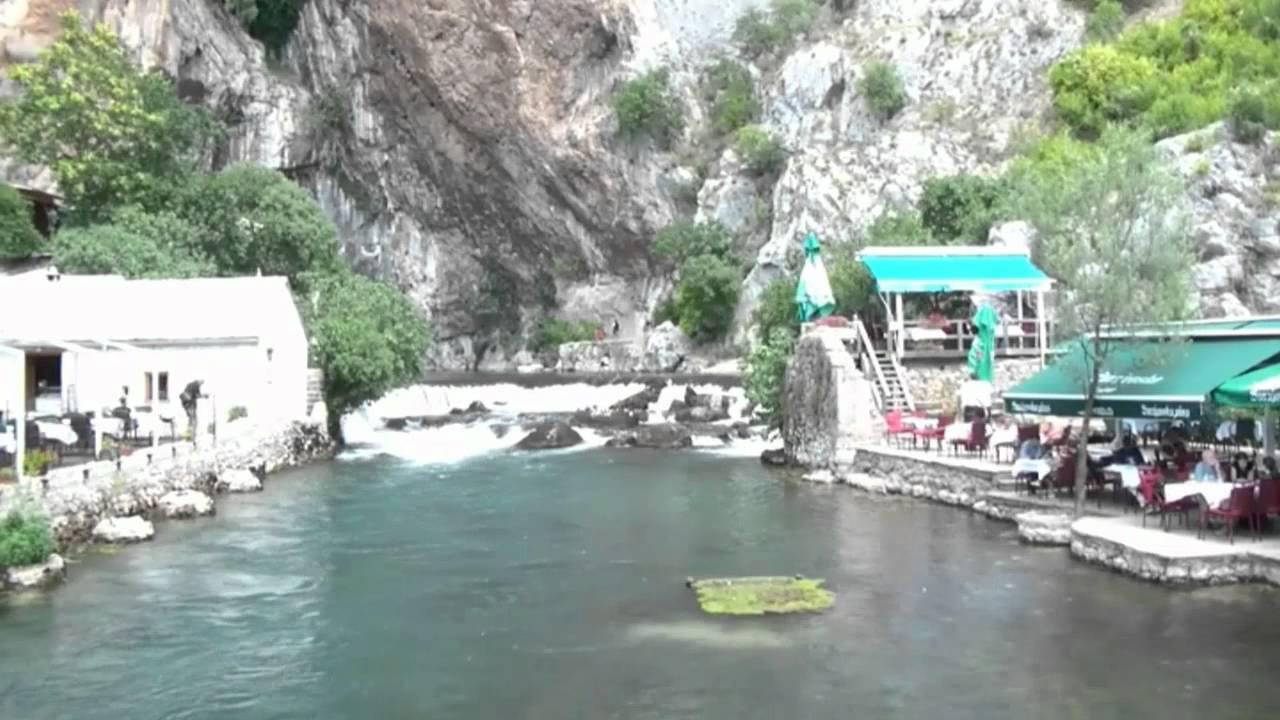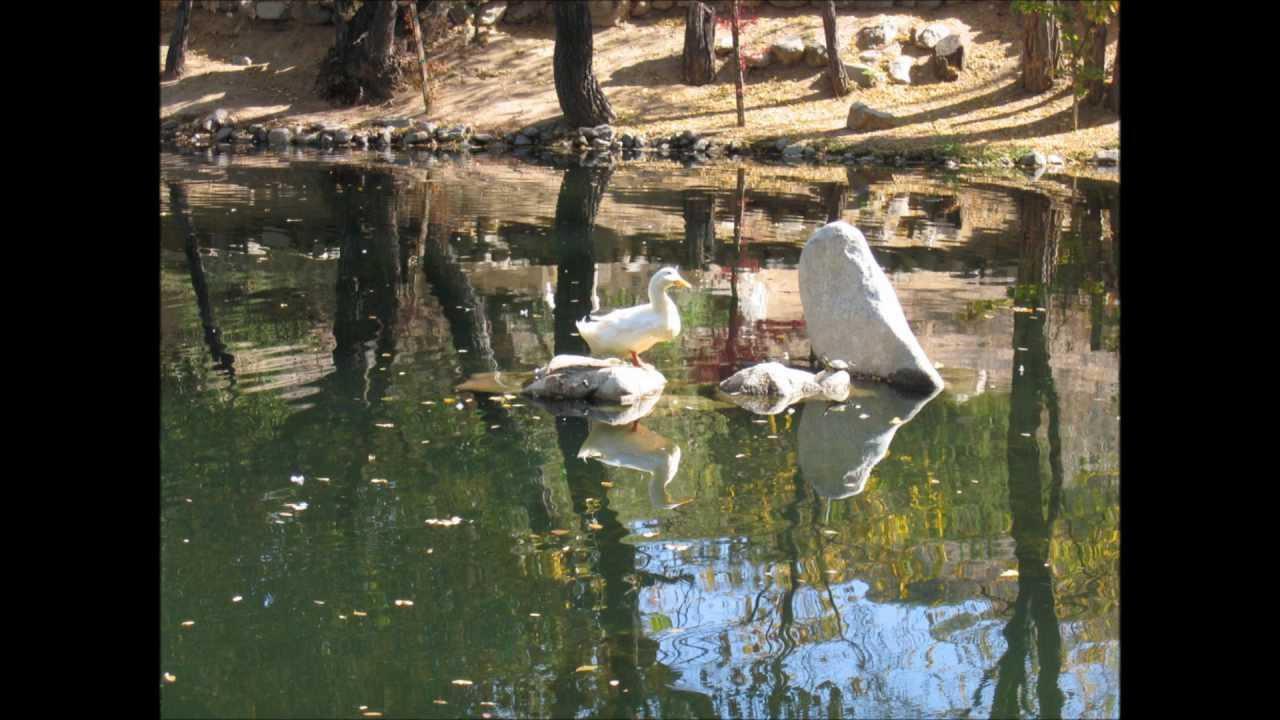The first image is the image on the left, the second image is the image on the right. For the images displayed, is the sentence "There is a body of water on the images." factually correct? Answer yes or no. Yes. 